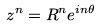<formula> <loc_0><loc_0><loc_500><loc_500>z ^ { n } = R ^ { n } e ^ { i n \theta }</formula> 